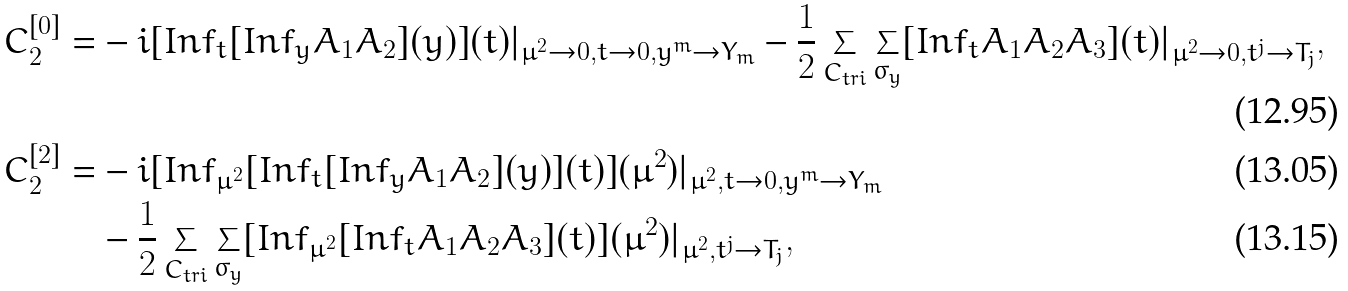Convert formula to latex. <formula><loc_0><loc_0><loc_500><loc_500>C _ { 2 } ^ { [ 0 ] } = & - i [ I n f _ { t } [ I n f _ { y } A _ { 1 } A _ { 2 } ] ( y ) ] ( t ) | _ { \mu ^ { 2 } \rightarrow 0 , t \rightarrow 0 , y ^ { m } \rightarrow Y _ { m } } - \frac { 1 } { 2 } \sum _ { C _ { t r i } } \sum _ { \sigma _ { y } } [ I n f _ { t } A _ { 1 } A _ { 2 } A _ { 3 } ] ( t ) | _ { \mu ^ { 2 } \rightarrow 0 , t ^ { j } \rightarrow T _ { j } } , \\ C _ { 2 } ^ { [ 2 ] } = & - i [ I n f _ { \mu ^ { 2 } } [ I n f _ { t } [ I n f _ { y } A _ { 1 } A _ { 2 } ] ( y ) ] ( t ) ] ( \mu ^ { 2 } ) | _ { \mu ^ { 2 } , t \rightarrow 0 , y ^ { m } \rightarrow Y _ { m } } \\ & - \frac { 1 } { 2 } \sum _ { C _ { t r i } } \sum _ { \sigma _ { y } } [ I n f _ { \mu ^ { 2 } } [ I n f _ { t } A _ { 1 } A _ { 2 } A _ { 3 } ] ( t ) ] ( \mu ^ { 2 } ) | _ { \mu ^ { 2 } , t ^ { j } \rightarrow T _ { j } } ,</formula> 